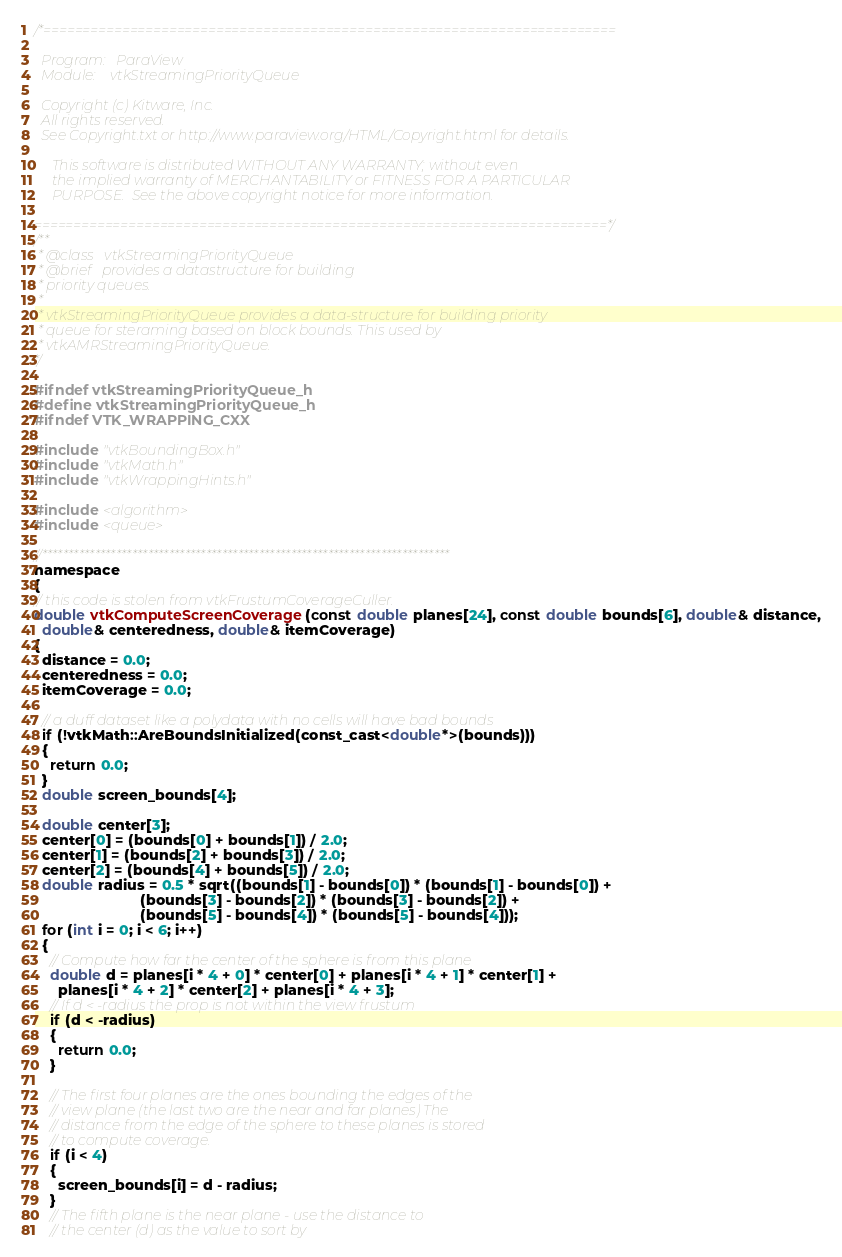<code> <loc_0><loc_0><loc_500><loc_500><_C_>/*=========================================================================

  Program:   ParaView
  Module:    vtkStreamingPriorityQueue

  Copyright (c) Kitware, Inc.
  All rights reserved.
  See Copyright.txt or http://www.paraview.org/HTML/Copyright.html for details.

     This software is distributed WITHOUT ANY WARRANTY; without even
     the implied warranty of MERCHANTABILITY or FITNESS FOR A PARTICULAR
     PURPOSE.  See the above copyright notice for more information.

=========================================================================*/
/**
 * @class   vtkStreamingPriorityQueue
 * @brief   provides a datastructure for building
 * priority queues.
 *
 * vtkStreamingPriorityQueue provides a data-structure for building priority
 * queue for steraming based on block bounds. This used by
 * vtkAMRStreamingPriorityQueue.
*/

#ifndef vtkStreamingPriorityQueue_h
#define vtkStreamingPriorityQueue_h
#ifndef VTK_WRAPPING_CXX

#include "vtkBoundingBox.h"
#include "vtkMath.h"
#include "vtkWrappingHints.h"

#include <algorithm>
#include <queue>

//*****************************************************************************
namespace
{
// this code is stolen from vtkFrustumCoverageCuller.
double vtkComputeScreenCoverage(const double planes[24], const double bounds[6], double& distance,
  double& centeredness, double& itemCoverage)
{
  distance = 0.0;
  centeredness = 0.0;
  itemCoverage = 0.0;

  // a duff dataset like a polydata with no cells will have bad bounds
  if (!vtkMath::AreBoundsInitialized(const_cast<double*>(bounds)))
  {
    return 0.0;
  }
  double screen_bounds[4];

  double center[3];
  center[0] = (bounds[0] + bounds[1]) / 2.0;
  center[1] = (bounds[2] + bounds[3]) / 2.0;
  center[2] = (bounds[4] + bounds[5]) / 2.0;
  double radius = 0.5 * sqrt((bounds[1] - bounds[0]) * (bounds[1] - bounds[0]) +
                          (bounds[3] - bounds[2]) * (bounds[3] - bounds[2]) +
                          (bounds[5] - bounds[4]) * (bounds[5] - bounds[4]));
  for (int i = 0; i < 6; i++)
  {
    // Compute how far the center of the sphere is from this plane
    double d = planes[i * 4 + 0] * center[0] + planes[i * 4 + 1] * center[1] +
      planes[i * 4 + 2] * center[2] + planes[i * 4 + 3];
    // If d < -radius the prop is not within the view frustum
    if (d < -radius)
    {
      return 0.0;
    }

    // The first four planes are the ones bounding the edges of the
    // view plane (the last two are the near and far planes) The
    // distance from the edge of the sphere to these planes is stored
    // to compute coverage.
    if (i < 4)
    {
      screen_bounds[i] = d - radius;
    }
    // The fifth plane is the near plane - use the distance to
    // the center (d) as the value to sort by</code> 